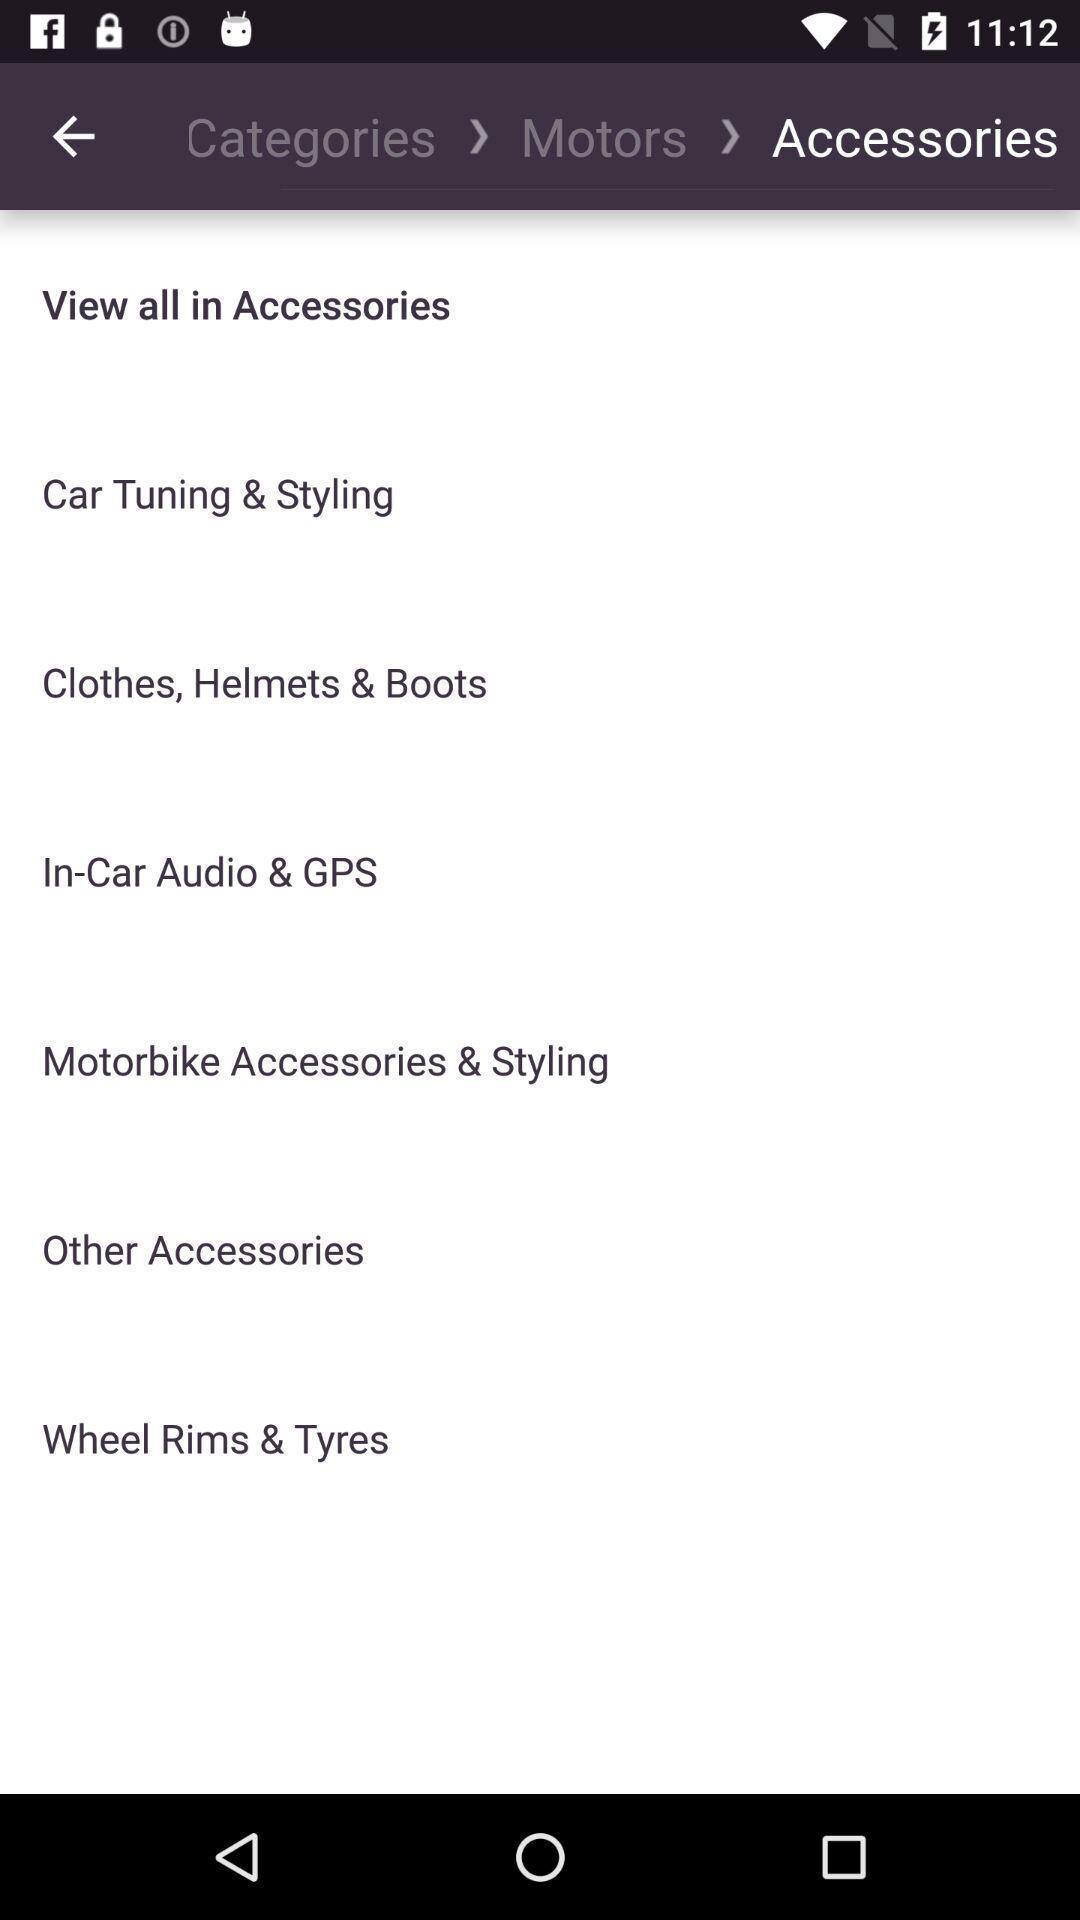What can you discern from this picture? Page displays list of accessories in app. 